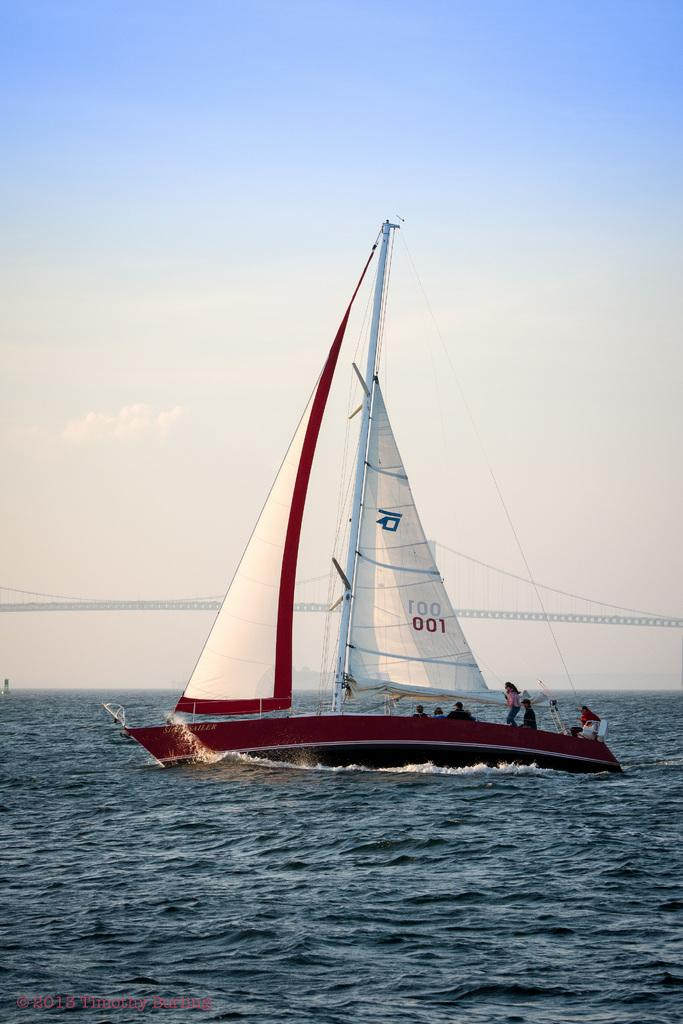What is in the water in the image? There is a boat in the water in the image. Who or what is on the boat? There are people on the boat. What can be seen in the background of the image? The sky is visible in the background of the image. What is written or displayed at the bottom of the image? There is some text at the bottom of the image. How does the distribution of boats in the image compare to the distribution of boats in a different image? There is no comparison to another image in the provided facts, so we cannot determine the distribution of boats in the image. 